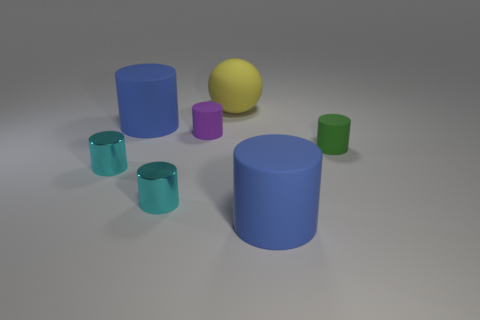Subtract 3 cylinders. How many cylinders are left? 3 Subtract all purple cylinders. How many cylinders are left? 5 Subtract all big blue matte cylinders. How many cylinders are left? 4 Subtract all brown cylinders. Subtract all blue cubes. How many cylinders are left? 6 Add 1 cyan shiny things. How many objects exist? 8 Subtract all cylinders. How many objects are left? 1 Add 2 tiny purple matte cylinders. How many tiny purple matte cylinders are left? 3 Add 1 big yellow objects. How many big yellow objects exist? 2 Subtract 0 cyan balls. How many objects are left? 7 Subtract all large matte cylinders. Subtract all yellow matte things. How many objects are left? 4 